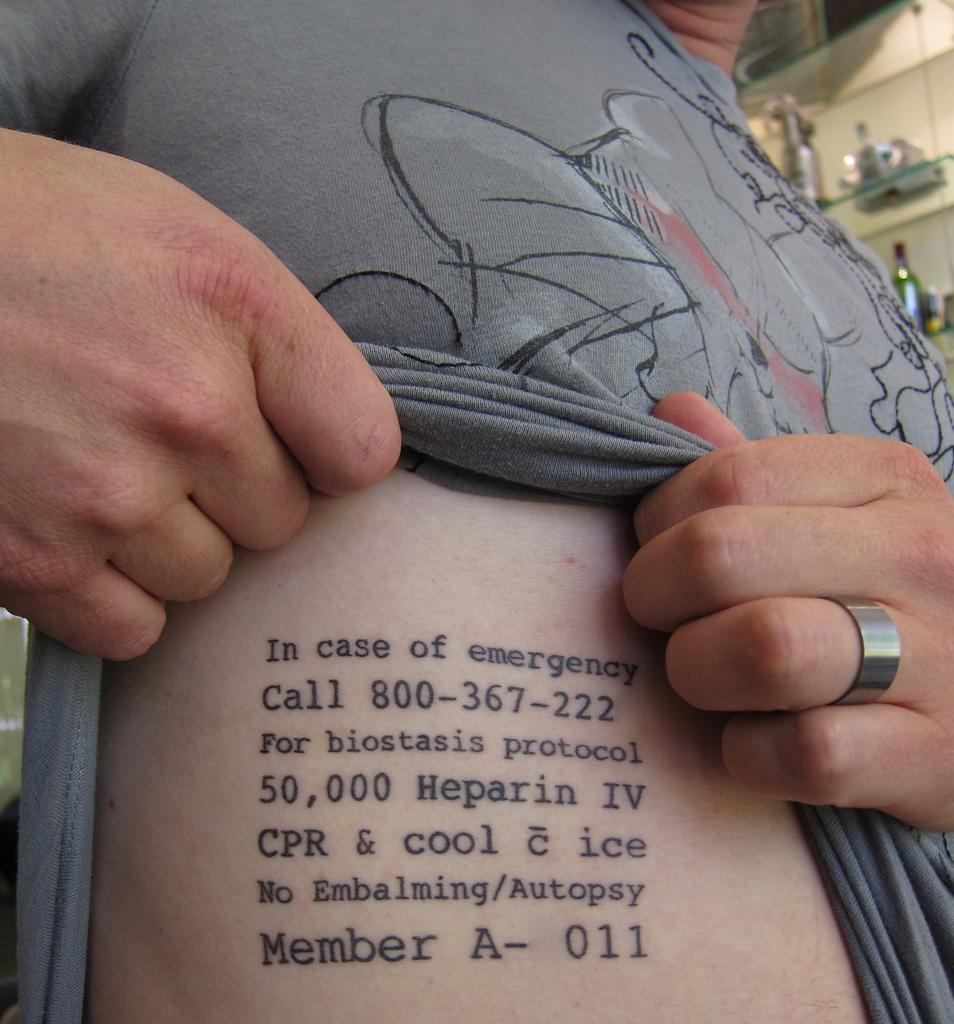What can be seen in the image? There is a person in the image. Can you describe the person's appearance? The person is wearing a ring and has writing on their body. What can be seen in the background of the image? There are bottles on racks in the background of the image, and the background appears blurry. What type of shoe is the boy wearing in the image? There is no boy present in the image, and no shoes are visible. 